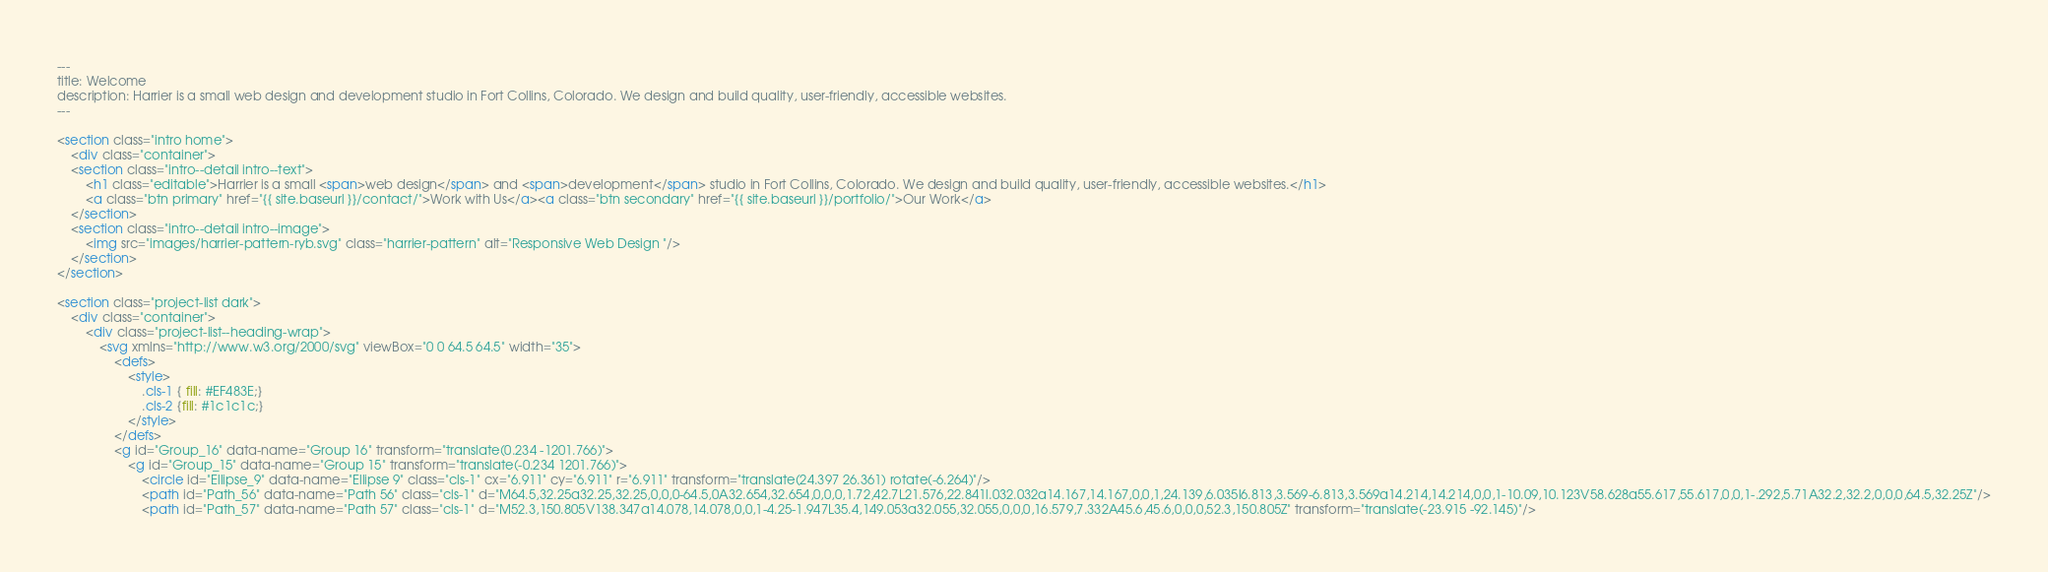<code> <loc_0><loc_0><loc_500><loc_500><_HTML_>---
title: Welcome
description: Harrier is a small web design and development studio in Fort Collins, Colorado. We design and build quality, user-friendly, accessible websites.
---

<section class="intro home">
	<div class="container">
	<section class="intro--detail intro--text">
		<h1 class="editable">Harrier is a small <span>web design</span> and <span>development</span> studio in Fort Collins, Colorado. We design and build quality, user-friendly, accessible websites.</h1>
		<a class="btn primary" href="{{ site.baseurl }}/contact/">Work with Us</a><a class="btn secondary" href="{{ site.baseurl }}/portfolio/">Our Work</a>
	</section>
	<section class="intro--detail intro--image">
		<img src="images/harrier-pattern-ryb.svg" class="harrier-pattern" alt="Responsive Web Design "/>
	</section>
</section>

<section class="project-list dark">
	<div class="container">
		<div class="project-list--heading-wrap">
			<svg xmlns="http://www.w3.org/2000/svg" viewBox="0 0 64.5 64.5" width="35">
				<defs>
					<style>
						.cls-1 { fill: #EF483E;}
						.cls-2 {fill: #1c1c1c;}
					</style>
				</defs>
				<g id="Group_16" data-name="Group 16" transform="translate(0.234 -1201.766)">
					<g id="Group_15" data-name="Group 15" transform="translate(-0.234 1201.766)">
						<circle id="Ellipse_9" data-name="Ellipse 9" class="cls-1" cx="6.911" cy="6.911" r="6.911" transform="translate(24.397 26.361) rotate(-6.264)"/>
						<path id="Path_56" data-name="Path 56" class="cls-1" d="M64.5,32.25a32.25,32.25,0,0,0-64.5,0A32.654,32.654,0,0,0,1.72,42.7L21.576,22.841l.032.032a14.167,14.167,0,0,1,24.139,6.035l6.813,3.569-6.813,3.569a14.214,14.214,0,0,1-10.09,10.123V58.628a55.617,55.617,0,0,1-.292,5.71A32.2,32.2,0,0,0,64.5,32.25Z"/>
						<path id="Path_57" data-name="Path 57" class="cls-1" d="M52.3,150.805V138.347a14.078,14.078,0,0,1-4.25-1.947L35.4,149.053a32.055,32.055,0,0,0,16.579,7.332A45.6,45.6,0,0,0,52.3,150.805Z" transform="translate(-23.915 -92.145)"/></code> 